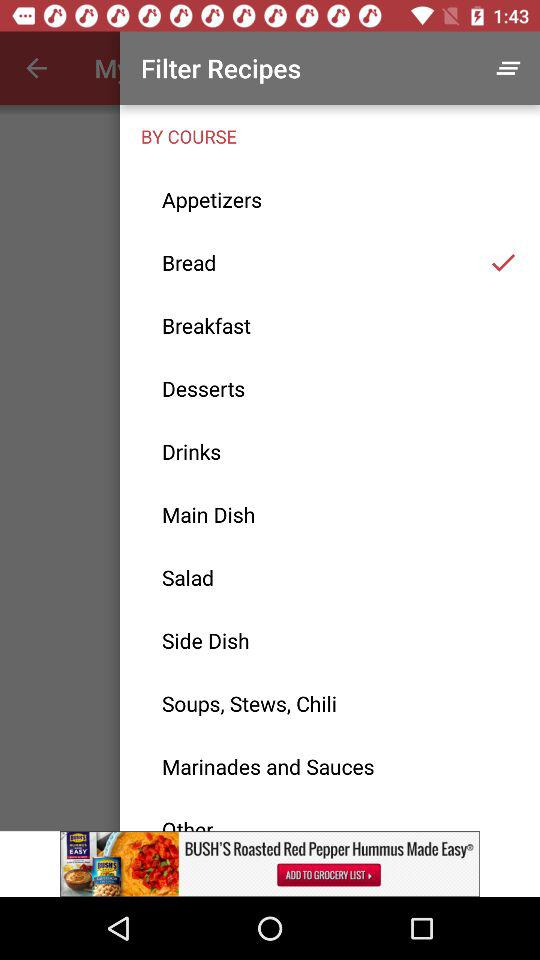What are the available courses? The available courses are "Appetizers", "Bread", "Breakfast", "Desserts", "Drinks", "Main Dish", "Salad", "Side Dish", "Soups, Stews, Chili" and "Marinades and Sauces". 